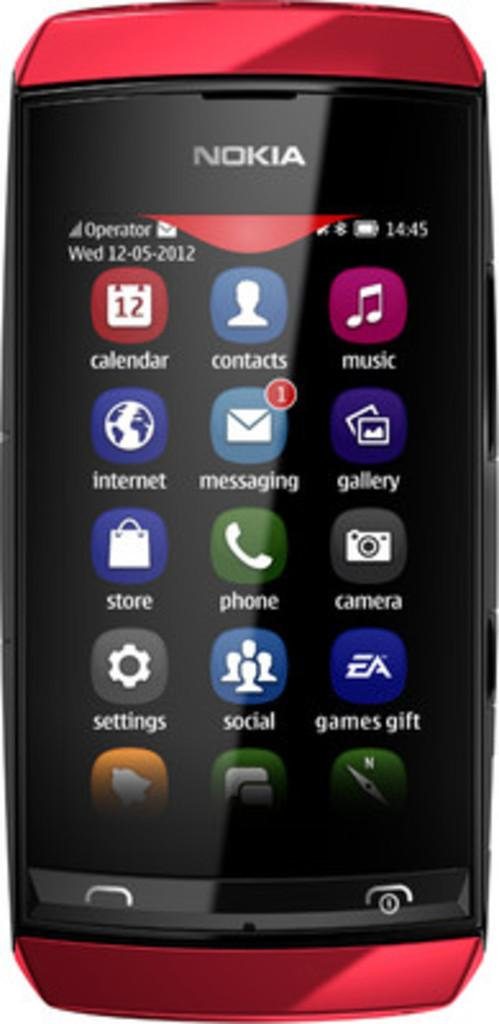<image>
Render a clear and concise summary of the photo. The date on the red Nokia phone shows it is Wednesday 12-05-2012. 